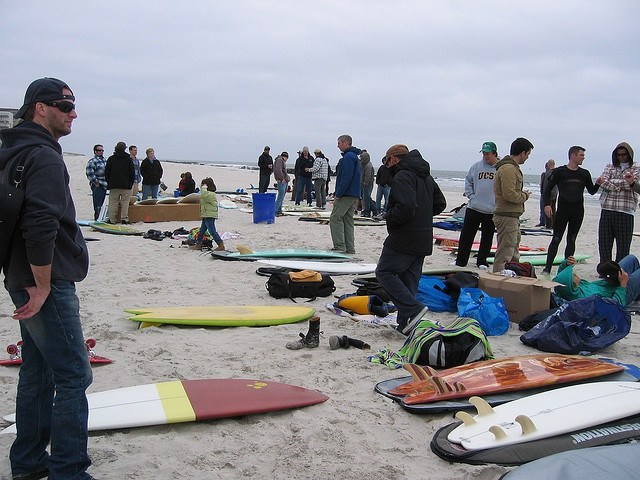Describe the objects in this image and their specific colors. I can see people in lightgray, black, gray, and maroon tones, people in lightgray, black, darkgray, gray, and navy tones, people in lightgray, black, darkgray, gray, and navy tones, surfboard in lightgray, brown, khaki, and darkgray tones, and surfboard in lightgray, darkgray, tan, and black tones in this image. 